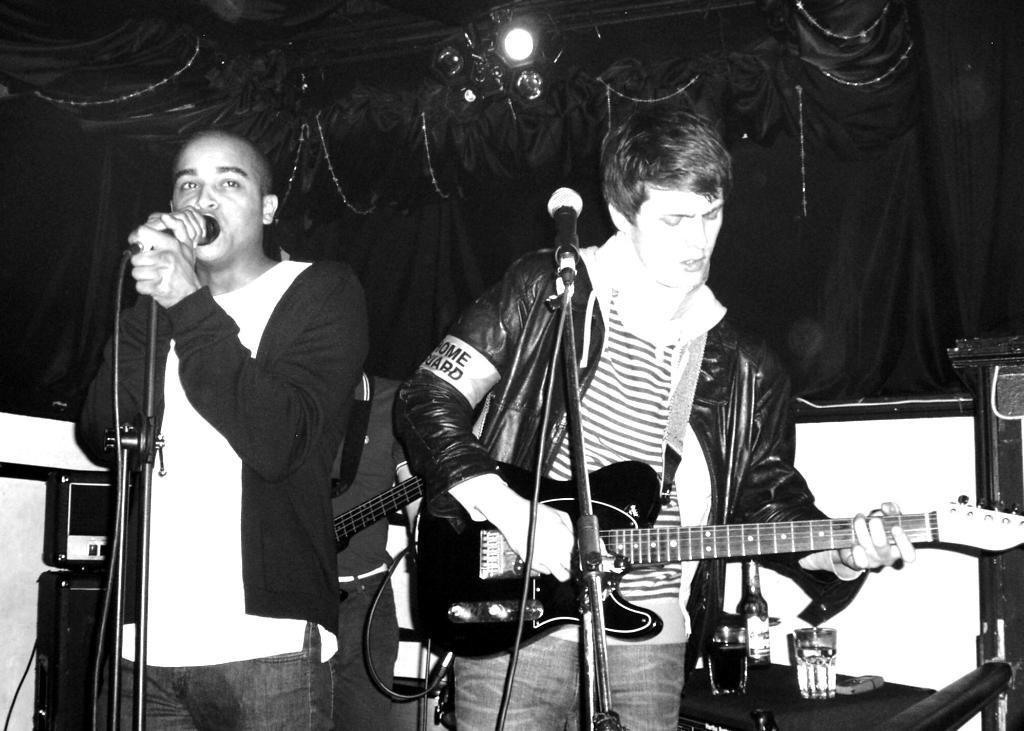What is the person wearing in the image? The person is wearing a black jacket in the image. What is the person doing while wearing the black jacket? The person is singing in the image. What object is in front of the person who is singing? There is a microphone in front of the person singing. How many people are in the image? There are two people in the image. What is the second person doing in the image? The second person is playing a guitar in the image. What object is in front of the person playing the guitar? There is a microphone in front of the person playing the guitar. Are there any plants visible in the image? No, there are no plants visible in the image. How hot is the temperature in the image? The temperature is not mentioned in the image, and it is not possible to determine the temperature based on the visual information provided. 